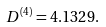Convert formula to latex. <formula><loc_0><loc_0><loc_500><loc_500>D ^ { ( 4 ) } = 4 . 1 3 2 9 .</formula> 